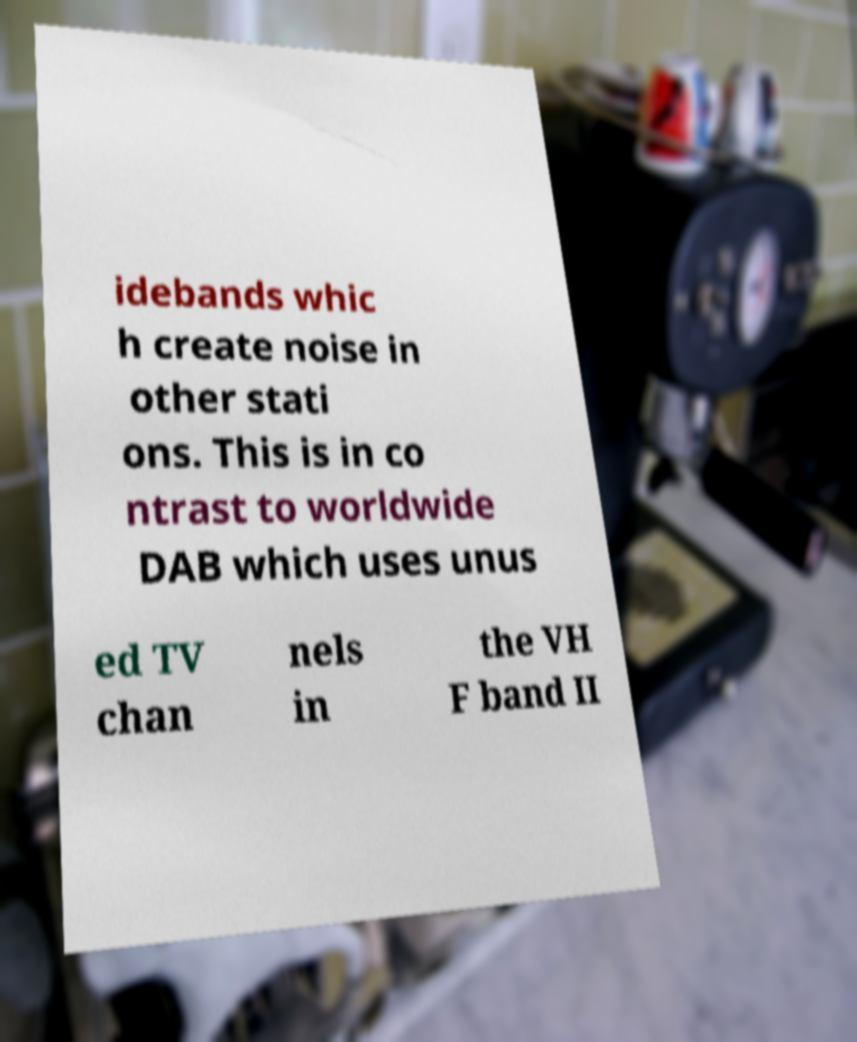For documentation purposes, I need the text within this image transcribed. Could you provide that? idebands whic h create noise in other stati ons. This is in co ntrast to worldwide DAB which uses unus ed TV chan nels in the VH F band II 